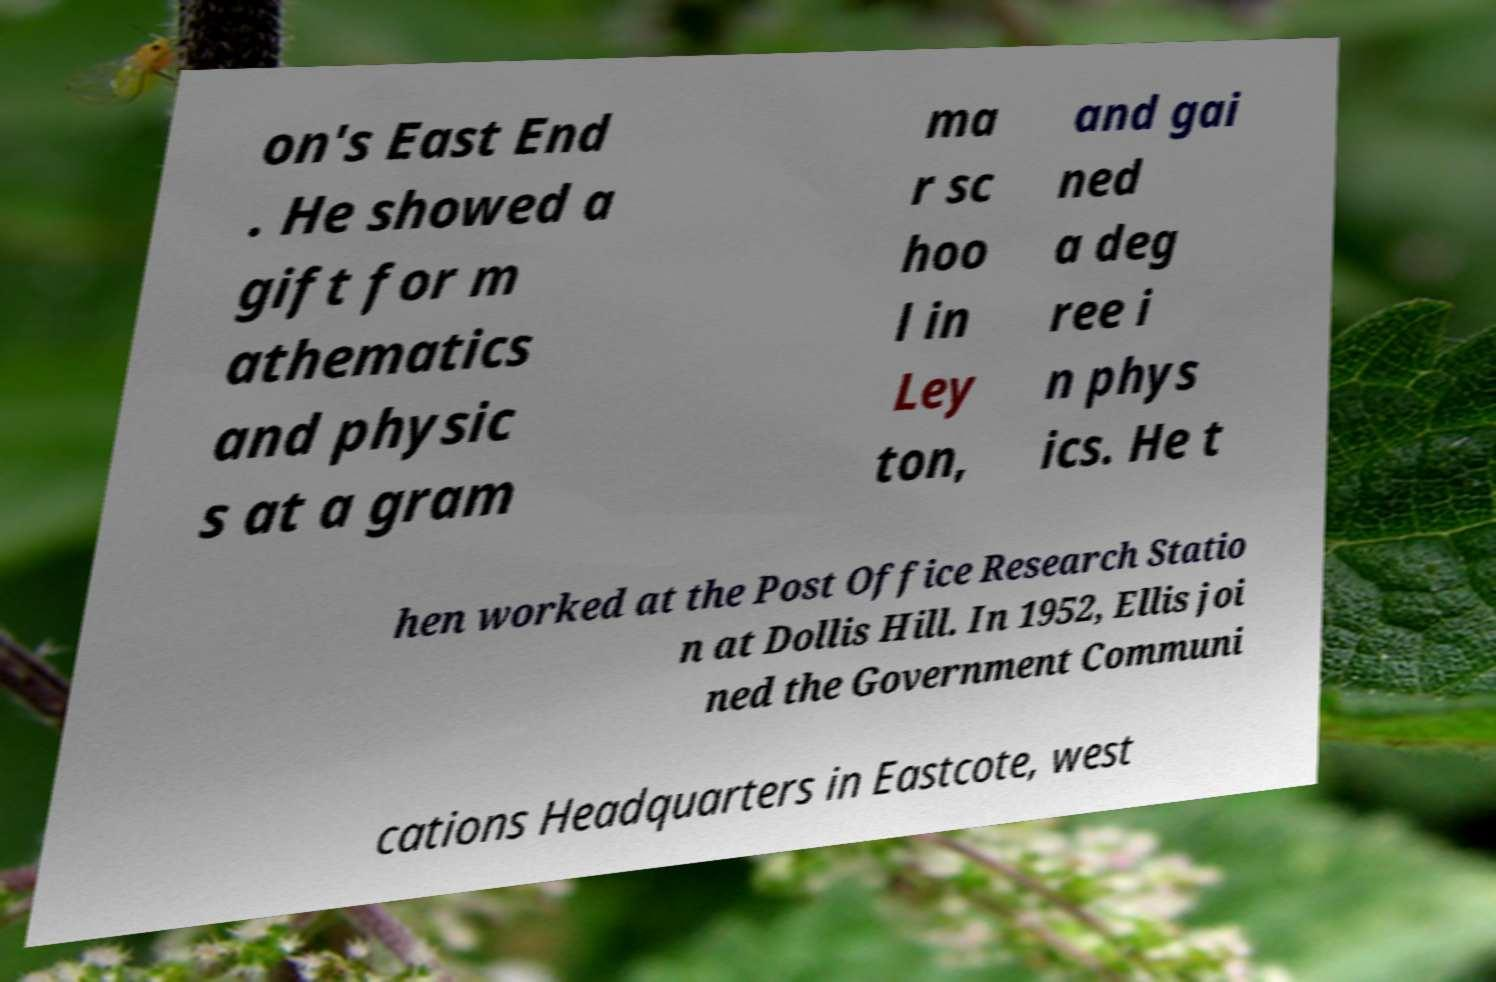I need the written content from this picture converted into text. Can you do that? on's East End . He showed a gift for m athematics and physic s at a gram ma r sc hoo l in Ley ton, and gai ned a deg ree i n phys ics. He t hen worked at the Post Office Research Statio n at Dollis Hill. In 1952, Ellis joi ned the Government Communi cations Headquarters in Eastcote, west 